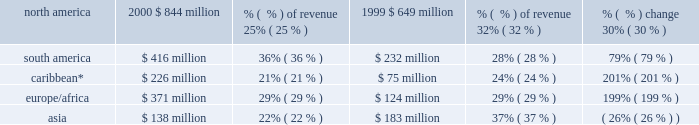The breakdown of aes 2019s gross margin for the years ended december 31 , 2000 and 1999 , based on the geographic region in which they were earned , is set forth below. .
* includes venezuela and colombia .
Selling , general and administrative expenses selling , general and administrative expenses increased $ 11 million , or 15% ( 15 % ) , to $ 82 million in 2000 from $ 71 million in 1999 .
Selling , general and administrative expenses as a percentage of revenues remained constant at 1% ( 1 % ) in both 2000 and 1999 .
The increase is due to an increase in business development activities .
Interest expense , net net interest expense increased $ 506 million , or 80% ( 80 % ) , to $ 1.1 billion in 2000 from $ 632 million in 1999 .
Interest expense as a percentage of revenues remained constant at 15% ( 15 % ) in both 2000 and 1999 .
Interest expense increased primarily due to the interest at new businesses , including drax , tiete , cilcorp and edc , as well as additional corporate interest costs resulting from the senior debt and convertible securities issued within the past two years .
Other income , net other income increased $ 16 million , or 107% ( 107 % ) , to $ 31 million in 2000 from $ 15 million in 1999 .
Other income includes foreign currency transaction gains and losses as well as other non-operating income .
The increase in other income is due primarily to a favorable legal judgment and the sale of development projects .
Severance and transaction costs during the fourth quarter of 2000 , the company incurred approximately $ 79 million of transaction and contractual severance costs related to the acquisition of ipalco .
Gain on sale of assets during 2000 , ipalco sold certain assets ( 2018 2018thermal assets 2019 2019 ) for approximately $ 162 million .
The transaction resulted in a gain to the company of approximately $ 31 million .
Of the net proceeds , $ 88 million was used to retire debt specifically assignable to the thermal assets .
During 1999 , the company recorded a $ 29 million gain ( before extraordinary loss ) from the buyout of its long-term power sales agreement at placerita .
The company received gross proceeds of $ 110 million which were offset by transaction related costs of $ 19 million and an impairment loss of $ 62 million to reduce the carrying value of the electric generation assets to their estimated fair value after termination of the contract .
The estimated fair value was determined by an independent appraisal .
Concurrent with the buyout of the power sales agreement , the company repaid the related non-recourse debt prior to its scheduled maturity and recorded an extraordinary loss of $ 11 million , net of income taxes. .
For 2000 , what is the implied revenue for the north america segment based on the margin , in millions ? \\n? 
Computations: (844 / 25%)
Answer: 3376.0. 